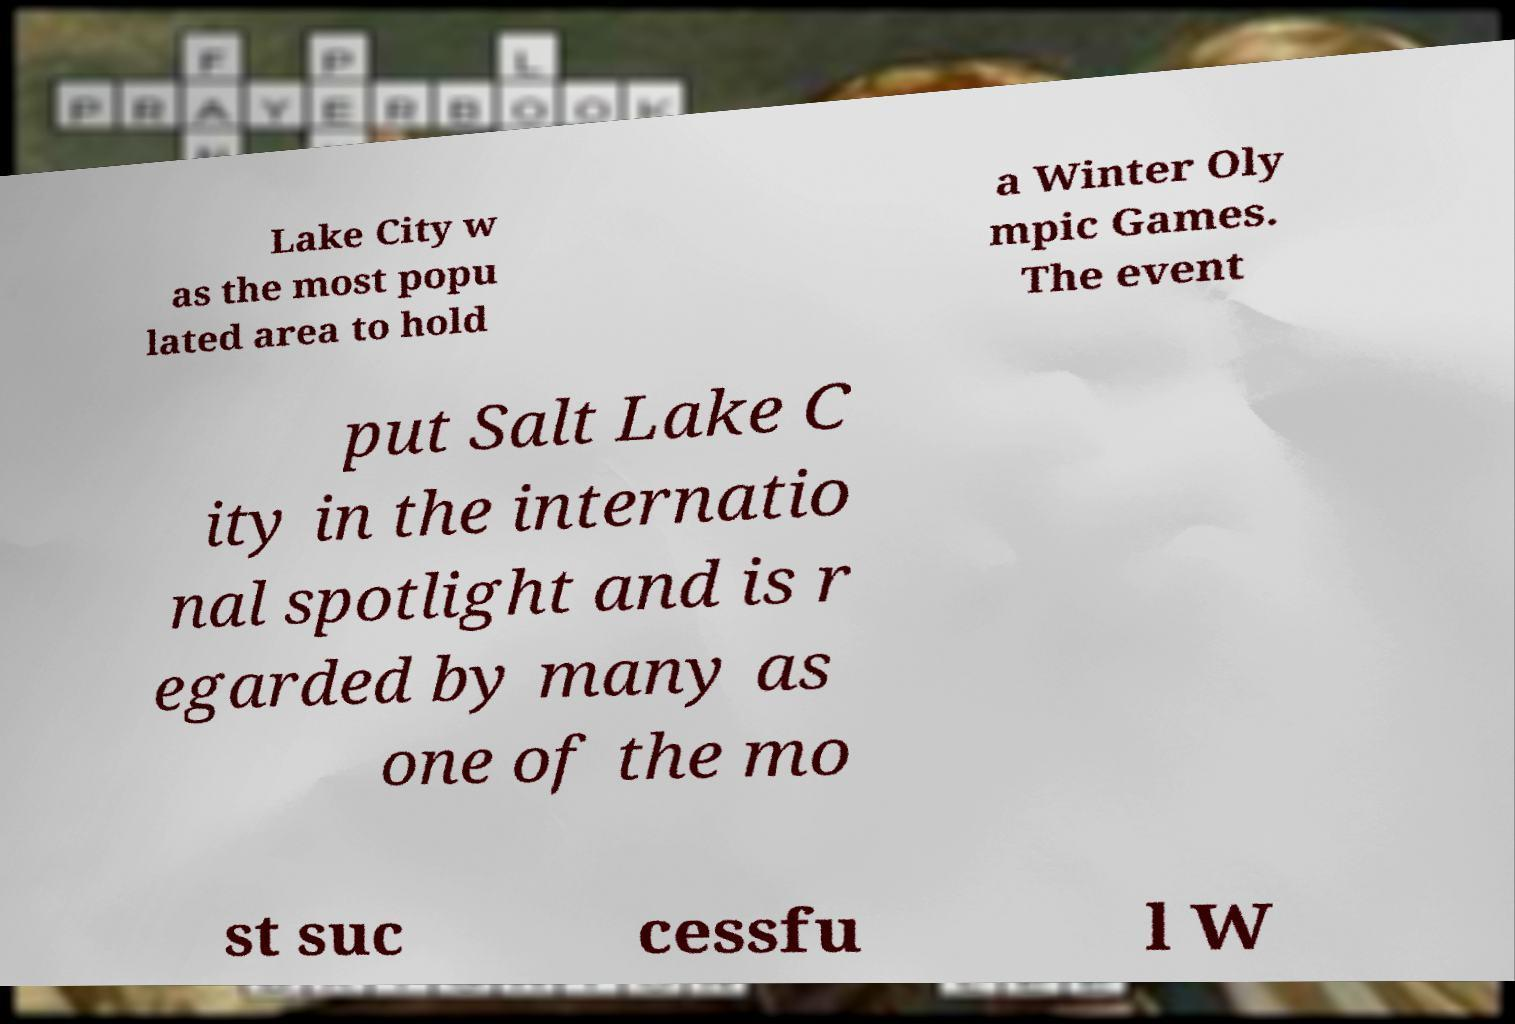Could you extract and type out the text from this image? Lake City w as the most popu lated area to hold a Winter Oly mpic Games. The event put Salt Lake C ity in the internatio nal spotlight and is r egarded by many as one of the mo st suc cessfu l W 